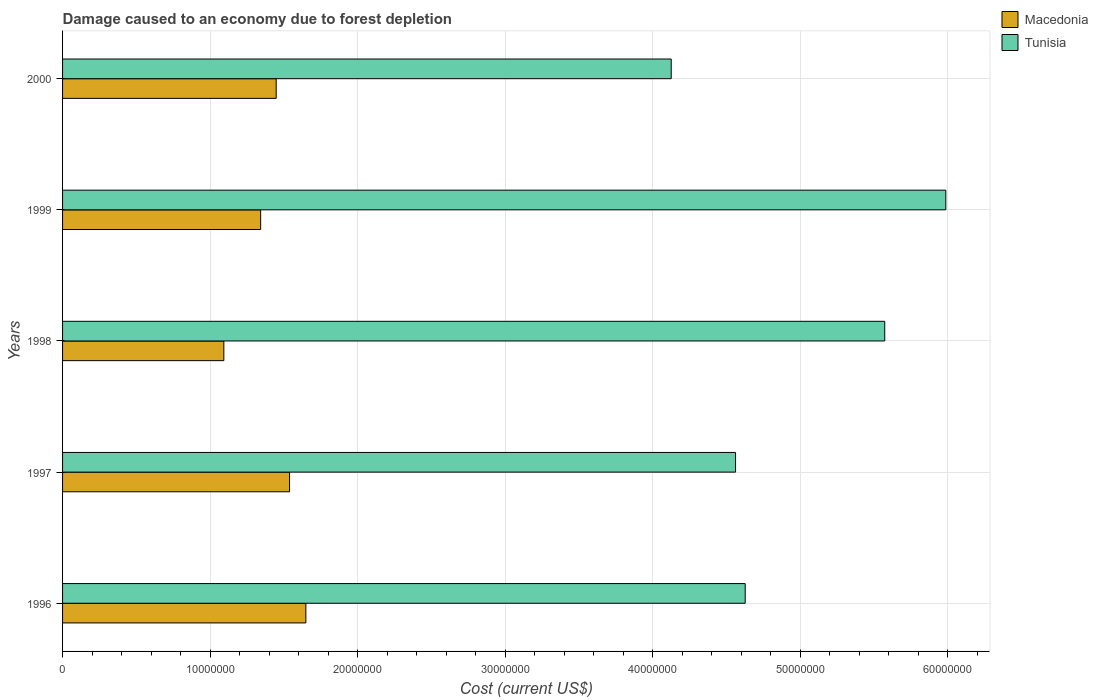How many groups of bars are there?
Your answer should be very brief. 5. Are the number of bars per tick equal to the number of legend labels?
Provide a short and direct response. Yes. Are the number of bars on each tick of the Y-axis equal?
Make the answer very short. Yes. How many bars are there on the 1st tick from the top?
Make the answer very short. 2. What is the label of the 3rd group of bars from the top?
Keep it short and to the point. 1998. In how many cases, is the number of bars for a given year not equal to the number of legend labels?
Offer a terse response. 0. What is the cost of damage caused due to forest depletion in Tunisia in 1999?
Keep it short and to the point. 5.99e+07. Across all years, what is the maximum cost of damage caused due to forest depletion in Tunisia?
Give a very brief answer. 5.99e+07. Across all years, what is the minimum cost of damage caused due to forest depletion in Macedonia?
Provide a succinct answer. 1.09e+07. What is the total cost of damage caused due to forest depletion in Tunisia in the graph?
Your response must be concise. 2.49e+08. What is the difference between the cost of damage caused due to forest depletion in Tunisia in 1998 and that in 2000?
Make the answer very short. 1.45e+07. What is the difference between the cost of damage caused due to forest depletion in Macedonia in 1996 and the cost of damage caused due to forest depletion in Tunisia in 1999?
Give a very brief answer. -4.34e+07. What is the average cost of damage caused due to forest depletion in Macedonia per year?
Your answer should be very brief. 1.41e+07. In the year 1997, what is the difference between the cost of damage caused due to forest depletion in Tunisia and cost of damage caused due to forest depletion in Macedonia?
Your answer should be compact. 3.02e+07. In how many years, is the cost of damage caused due to forest depletion in Tunisia greater than 28000000 US$?
Keep it short and to the point. 5. What is the ratio of the cost of damage caused due to forest depletion in Tunisia in 1997 to that in 1998?
Your response must be concise. 0.82. What is the difference between the highest and the second highest cost of damage caused due to forest depletion in Tunisia?
Your response must be concise. 4.14e+06. What is the difference between the highest and the lowest cost of damage caused due to forest depletion in Tunisia?
Provide a succinct answer. 1.86e+07. Is the sum of the cost of damage caused due to forest depletion in Macedonia in 1996 and 1997 greater than the maximum cost of damage caused due to forest depletion in Tunisia across all years?
Your response must be concise. No. What does the 2nd bar from the top in 1997 represents?
Offer a very short reply. Macedonia. What does the 1st bar from the bottom in 1998 represents?
Provide a short and direct response. Macedonia. How many years are there in the graph?
Offer a terse response. 5. What is the difference between two consecutive major ticks on the X-axis?
Offer a terse response. 1.00e+07. Where does the legend appear in the graph?
Provide a short and direct response. Top right. What is the title of the graph?
Provide a succinct answer. Damage caused to an economy due to forest depletion. Does "Nigeria" appear as one of the legend labels in the graph?
Keep it short and to the point. No. What is the label or title of the X-axis?
Provide a short and direct response. Cost (current US$). What is the label or title of the Y-axis?
Your response must be concise. Years. What is the Cost (current US$) in Macedonia in 1996?
Ensure brevity in your answer.  1.65e+07. What is the Cost (current US$) in Tunisia in 1996?
Offer a very short reply. 4.63e+07. What is the Cost (current US$) in Macedonia in 1997?
Your answer should be very brief. 1.54e+07. What is the Cost (current US$) in Tunisia in 1997?
Give a very brief answer. 4.56e+07. What is the Cost (current US$) in Macedonia in 1998?
Your response must be concise. 1.09e+07. What is the Cost (current US$) in Tunisia in 1998?
Your answer should be very brief. 5.57e+07. What is the Cost (current US$) in Macedonia in 1999?
Provide a short and direct response. 1.34e+07. What is the Cost (current US$) of Tunisia in 1999?
Give a very brief answer. 5.99e+07. What is the Cost (current US$) of Macedonia in 2000?
Give a very brief answer. 1.45e+07. What is the Cost (current US$) of Tunisia in 2000?
Your answer should be very brief. 4.13e+07. Across all years, what is the maximum Cost (current US$) of Macedonia?
Give a very brief answer. 1.65e+07. Across all years, what is the maximum Cost (current US$) in Tunisia?
Ensure brevity in your answer.  5.99e+07. Across all years, what is the minimum Cost (current US$) of Macedonia?
Offer a very short reply. 1.09e+07. Across all years, what is the minimum Cost (current US$) of Tunisia?
Offer a terse response. 4.13e+07. What is the total Cost (current US$) in Macedonia in the graph?
Keep it short and to the point. 7.07e+07. What is the total Cost (current US$) in Tunisia in the graph?
Your answer should be very brief. 2.49e+08. What is the difference between the Cost (current US$) of Macedonia in 1996 and that in 1997?
Give a very brief answer. 1.11e+06. What is the difference between the Cost (current US$) of Tunisia in 1996 and that in 1997?
Your response must be concise. 6.54e+05. What is the difference between the Cost (current US$) in Macedonia in 1996 and that in 1998?
Your answer should be very brief. 5.56e+06. What is the difference between the Cost (current US$) in Tunisia in 1996 and that in 1998?
Your response must be concise. -9.46e+06. What is the difference between the Cost (current US$) in Macedonia in 1996 and that in 1999?
Ensure brevity in your answer.  3.06e+06. What is the difference between the Cost (current US$) of Tunisia in 1996 and that in 1999?
Make the answer very short. -1.36e+07. What is the difference between the Cost (current US$) of Macedonia in 1996 and that in 2000?
Provide a short and direct response. 2.01e+06. What is the difference between the Cost (current US$) of Tunisia in 1996 and that in 2000?
Give a very brief answer. 5.01e+06. What is the difference between the Cost (current US$) of Macedonia in 1997 and that in 1998?
Keep it short and to the point. 4.45e+06. What is the difference between the Cost (current US$) of Tunisia in 1997 and that in 1998?
Provide a short and direct response. -1.01e+07. What is the difference between the Cost (current US$) in Macedonia in 1997 and that in 1999?
Ensure brevity in your answer.  1.96e+06. What is the difference between the Cost (current US$) in Tunisia in 1997 and that in 1999?
Your response must be concise. -1.43e+07. What is the difference between the Cost (current US$) in Macedonia in 1997 and that in 2000?
Give a very brief answer. 9.07e+05. What is the difference between the Cost (current US$) of Tunisia in 1997 and that in 2000?
Your answer should be compact. 4.36e+06. What is the difference between the Cost (current US$) of Macedonia in 1998 and that in 1999?
Offer a very short reply. -2.50e+06. What is the difference between the Cost (current US$) in Tunisia in 1998 and that in 1999?
Provide a short and direct response. -4.14e+06. What is the difference between the Cost (current US$) of Macedonia in 1998 and that in 2000?
Keep it short and to the point. -3.55e+06. What is the difference between the Cost (current US$) of Tunisia in 1998 and that in 2000?
Your response must be concise. 1.45e+07. What is the difference between the Cost (current US$) of Macedonia in 1999 and that in 2000?
Ensure brevity in your answer.  -1.05e+06. What is the difference between the Cost (current US$) of Tunisia in 1999 and that in 2000?
Keep it short and to the point. 1.86e+07. What is the difference between the Cost (current US$) in Macedonia in 1996 and the Cost (current US$) in Tunisia in 1997?
Offer a terse response. -2.91e+07. What is the difference between the Cost (current US$) in Macedonia in 1996 and the Cost (current US$) in Tunisia in 1998?
Your answer should be very brief. -3.92e+07. What is the difference between the Cost (current US$) in Macedonia in 1996 and the Cost (current US$) in Tunisia in 1999?
Your answer should be compact. -4.34e+07. What is the difference between the Cost (current US$) in Macedonia in 1996 and the Cost (current US$) in Tunisia in 2000?
Give a very brief answer. -2.48e+07. What is the difference between the Cost (current US$) of Macedonia in 1997 and the Cost (current US$) of Tunisia in 1998?
Make the answer very short. -4.03e+07. What is the difference between the Cost (current US$) of Macedonia in 1997 and the Cost (current US$) of Tunisia in 1999?
Offer a terse response. -4.45e+07. What is the difference between the Cost (current US$) of Macedonia in 1997 and the Cost (current US$) of Tunisia in 2000?
Make the answer very short. -2.59e+07. What is the difference between the Cost (current US$) in Macedonia in 1998 and the Cost (current US$) in Tunisia in 1999?
Ensure brevity in your answer.  -4.89e+07. What is the difference between the Cost (current US$) in Macedonia in 1998 and the Cost (current US$) in Tunisia in 2000?
Keep it short and to the point. -3.03e+07. What is the difference between the Cost (current US$) of Macedonia in 1999 and the Cost (current US$) of Tunisia in 2000?
Your answer should be very brief. -2.78e+07. What is the average Cost (current US$) of Macedonia per year?
Keep it short and to the point. 1.41e+07. What is the average Cost (current US$) in Tunisia per year?
Make the answer very short. 4.98e+07. In the year 1996, what is the difference between the Cost (current US$) in Macedonia and Cost (current US$) in Tunisia?
Your response must be concise. -2.98e+07. In the year 1997, what is the difference between the Cost (current US$) in Macedonia and Cost (current US$) in Tunisia?
Make the answer very short. -3.02e+07. In the year 1998, what is the difference between the Cost (current US$) in Macedonia and Cost (current US$) in Tunisia?
Your answer should be very brief. -4.48e+07. In the year 1999, what is the difference between the Cost (current US$) in Macedonia and Cost (current US$) in Tunisia?
Provide a succinct answer. -4.64e+07. In the year 2000, what is the difference between the Cost (current US$) of Macedonia and Cost (current US$) of Tunisia?
Ensure brevity in your answer.  -2.68e+07. What is the ratio of the Cost (current US$) in Macedonia in 1996 to that in 1997?
Your response must be concise. 1.07. What is the ratio of the Cost (current US$) of Tunisia in 1996 to that in 1997?
Provide a succinct answer. 1.01. What is the ratio of the Cost (current US$) of Macedonia in 1996 to that in 1998?
Your response must be concise. 1.51. What is the ratio of the Cost (current US$) in Tunisia in 1996 to that in 1998?
Offer a very short reply. 0.83. What is the ratio of the Cost (current US$) of Macedonia in 1996 to that in 1999?
Give a very brief answer. 1.23. What is the ratio of the Cost (current US$) in Tunisia in 1996 to that in 1999?
Your answer should be very brief. 0.77. What is the ratio of the Cost (current US$) of Macedonia in 1996 to that in 2000?
Ensure brevity in your answer.  1.14. What is the ratio of the Cost (current US$) in Tunisia in 1996 to that in 2000?
Make the answer very short. 1.12. What is the ratio of the Cost (current US$) in Macedonia in 1997 to that in 1998?
Ensure brevity in your answer.  1.41. What is the ratio of the Cost (current US$) in Tunisia in 1997 to that in 1998?
Your answer should be compact. 0.82. What is the ratio of the Cost (current US$) of Macedonia in 1997 to that in 1999?
Your answer should be compact. 1.15. What is the ratio of the Cost (current US$) in Tunisia in 1997 to that in 1999?
Offer a terse response. 0.76. What is the ratio of the Cost (current US$) in Macedonia in 1997 to that in 2000?
Offer a very short reply. 1.06. What is the ratio of the Cost (current US$) in Tunisia in 1997 to that in 2000?
Offer a terse response. 1.11. What is the ratio of the Cost (current US$) in Macedonia in 1998 to that in 1999?
Provide a short and direct response. 0.81. What is the ratio of the Cost (current US$) of Tunisia in 1998 to that in 1999?
Your answer should be compact. 0.93. What is the ratio of the Cost (current US$) of Macedonia in 1998 to that in 2000?
Offer a terse response. 0.76. What is the ratio of the Cost (current US$) in Tunisia in 1998 to that in 2000?
Make the answer very short. 1.35. What is the ratio of the Cost (current US$) of Macedonia in 1999 to that in 2000?
Ensure brevity in your answer.  0.93. What is the ratio of the Cost (current US$) in Tunisia in 1999 to that in 2000?
Ensure brevity in your answer.  1.45. What is the difference between the highest and the second highest Cost (current US$) of Macedonia?
Keep it short and to the point. 1.11e+06. What is the difference between the highest and the second highest Cost (current US$) of Tunisia?
Keep it short and to the point. 4.14e+06. What is the difference between the highest and the lowest Cost (current US$) in Macedonia?
Keep it short and to the point. 5.56e+06. What is the difference between the highest and the lowest Cost (current US$) in Tunisia?
Your response must be concise. 1.86e+07. 